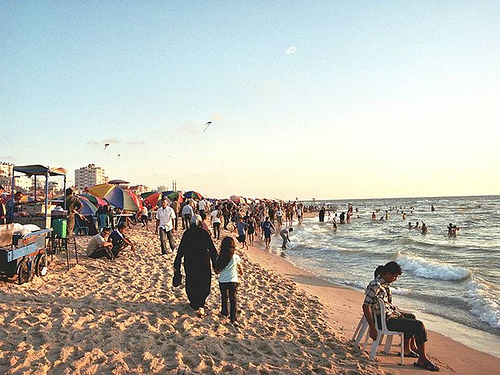Which place is it? The picture is taken on a bustling beach, likely a popular coastal destination filled with tourists and locals enjoying the sandy shores and ocean waves. 